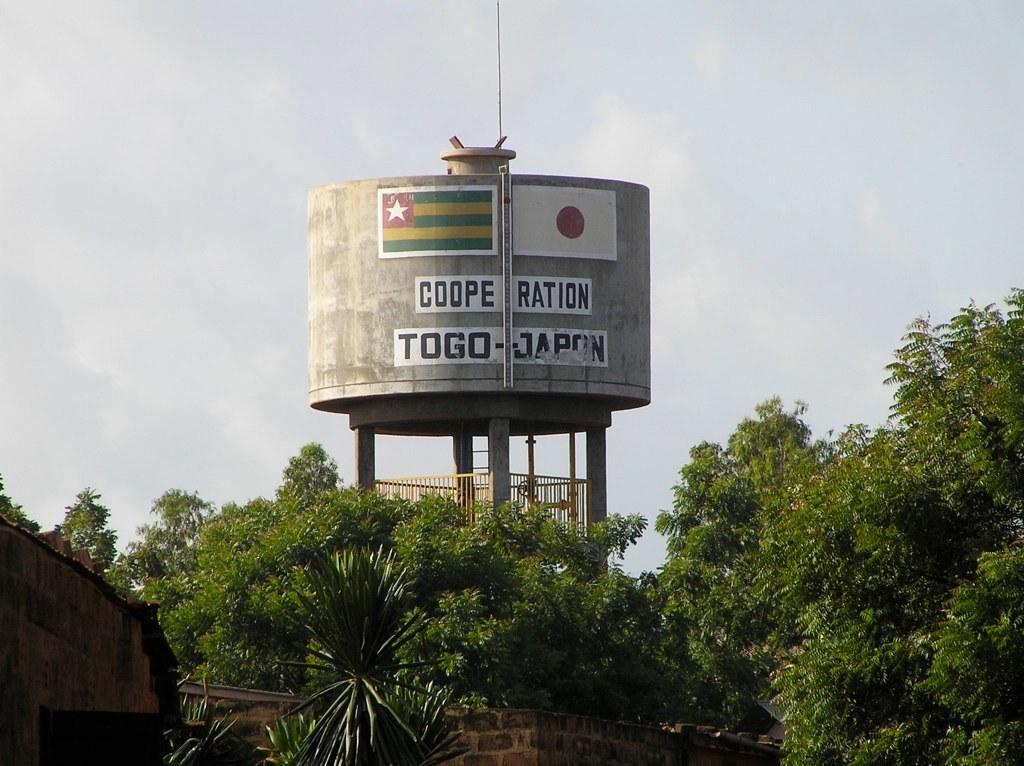Describe this image in one or two sentences. In the foreground of the picture I can see the trees. It is looking like a house on the bottom left side. In the background, I can see the tank construction. I can see the painting of flags and text on the tank. There are clouds in the sky. 